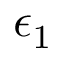<formula> <loc_0><loc_0><loc_500><loc_500>\epsilon _ { 1 }</formula> 